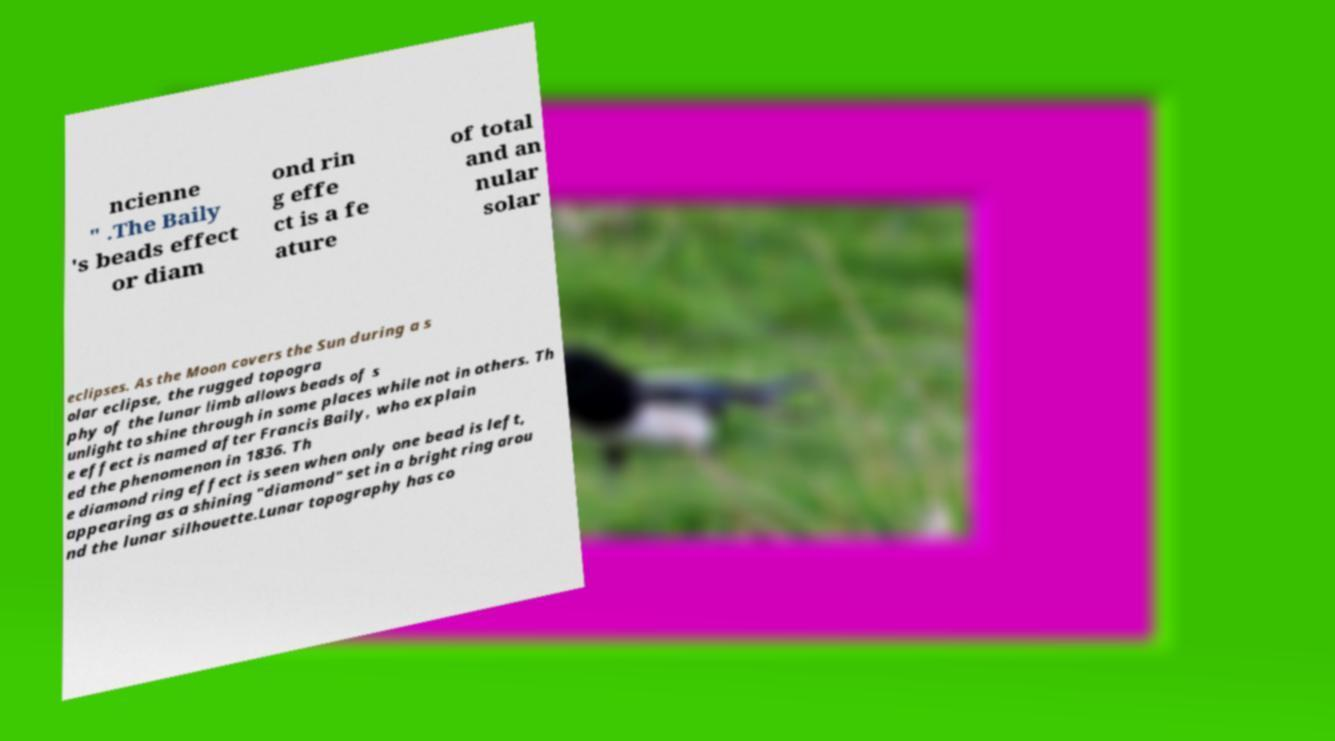I need the written content from this picture converted into text. Can you do that? ncienne " .The Baily 's beads effect or diam ond rin g effe ct is a fe ature of total and an nular solar eclipses. As the Moon covers the Sun during a s olar eclipse, the rugged topogra phy of the lunar limb allows beads of s unlight to shine through in some places while not in others. Th e effect is named after Francis Baily, who explain ed the phenomenon in 1836. Th e diamond ring effect is seen when only one bead is left, appearing as a shining "diamond" set in a bright ring arou nd the lunar silhouette.Lunar topography has co 